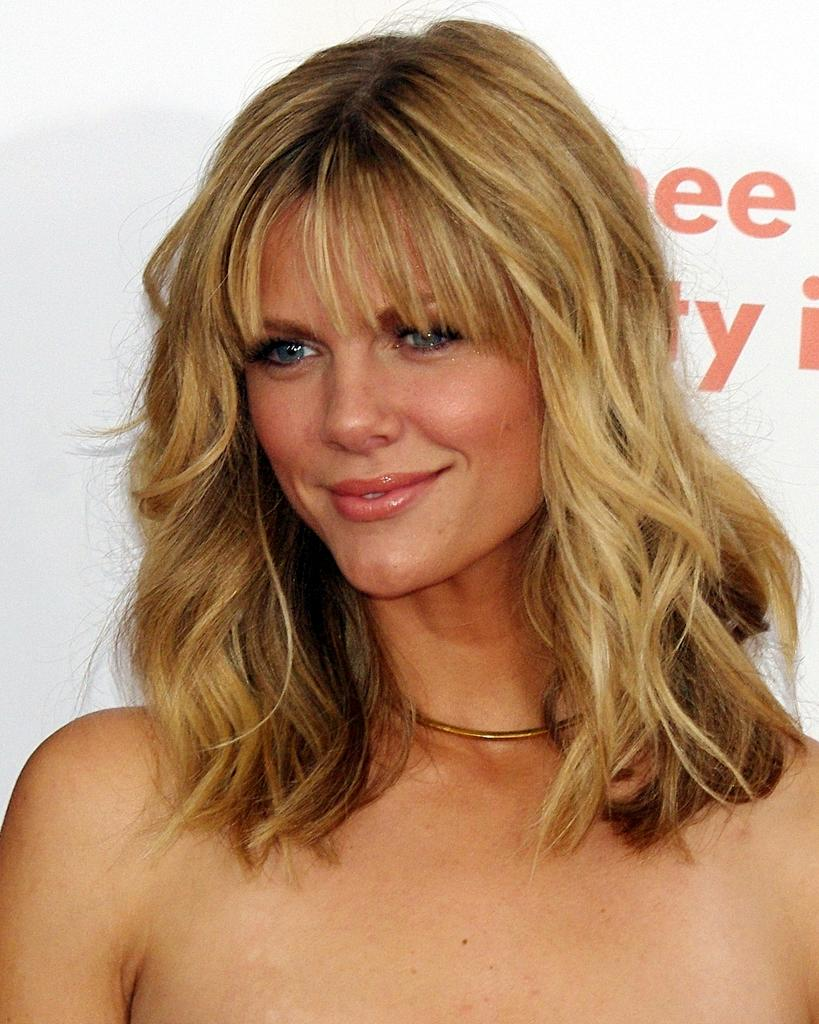Who is present in the image? There is a woman in the image. What is the woman's facial expression? The woman is smiling. What else can be seen in the image besides the woman? There is text visible in the background of the image. How many times does the woman sneeze in the image? There is no indication of the woman sneezing in the image, so it cannot be determined. What type of nest can be seen in the image? There is no nest present in the image. 